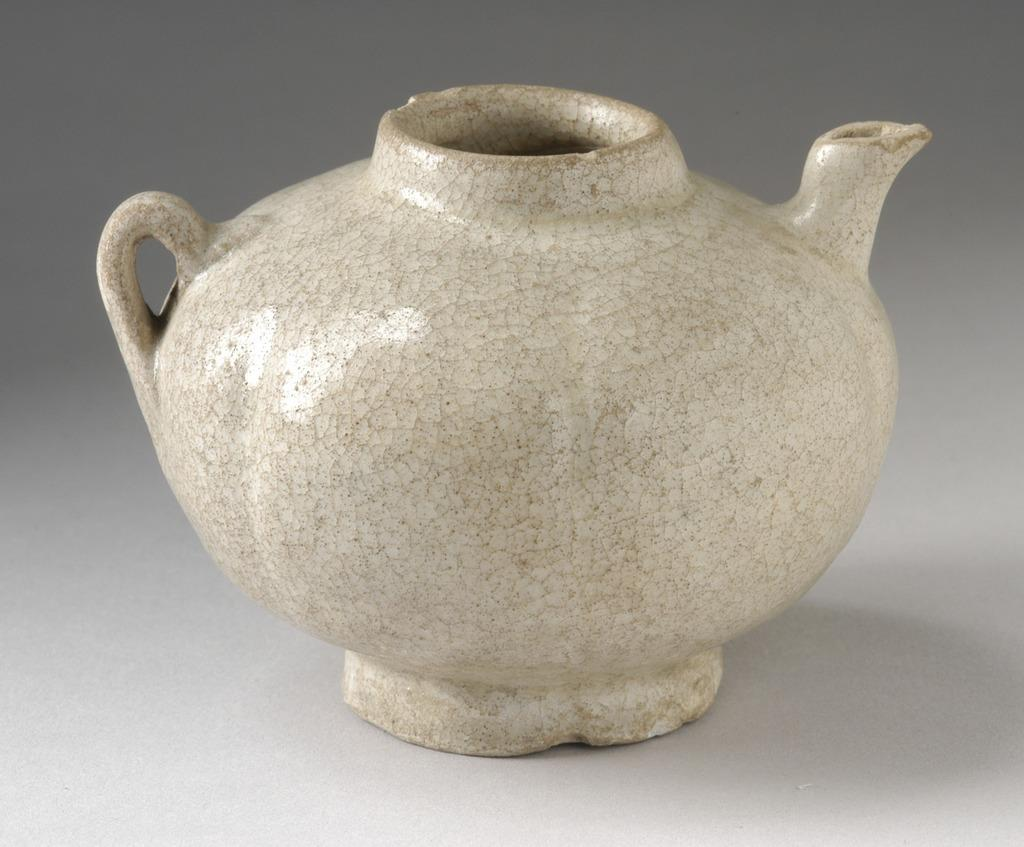What is the main object in the center of the image? There is a pot in the center of the image. What is the color of the table that is visible in the image? The table is white in color. What time is displayed on the clock in the image? There is no clock present in the image, so we cannot determine the time. 